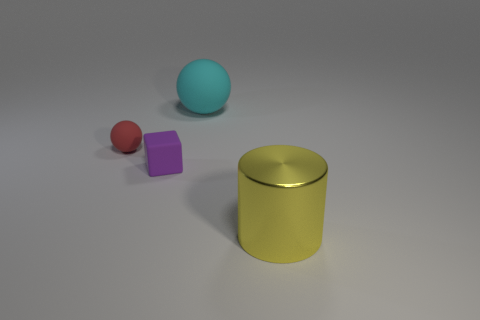The large object behind the object that is to the right of the cyan ball is what color?
Give a very brief answer. Cyan. Are there fewer yellow cylinders to the right of the large metallic object than small matte cubes behind the red matte thing?
Provide a succinct answer. No. There is a purple rubber block; is its size the same as the rubber sphere on the left side of the purple matte block?
Provide a succinct answer. Yes. There is a object that is on the left side of the big ball and to the right of the small red matte object; what shape is it?
Offer a terse response. Cube. There is a cyan sphere that is the same material as the small red sphere; what size is it?
Provide a succinct answer. Large. There is a matte thing that is right of the small purple block; what number of metal things are behind it?
Provide a succinct answer. 0. Is the yellow object in front of the red matte object made of the same material as the purple cube?
Your answer should be very brief. No. Is there any other thing that is the same material as the small sphere?
Provide a succinct answer. Yes. There is a ball on the right side of the rubber ball on the left side of the big matte ball; what size is it?
Keep it short and to the point. Large. There is a ball behind the sphere that is to the left of the rubber sphere right of the purple block; how big is it?
Your answer should be very brief. Large. 